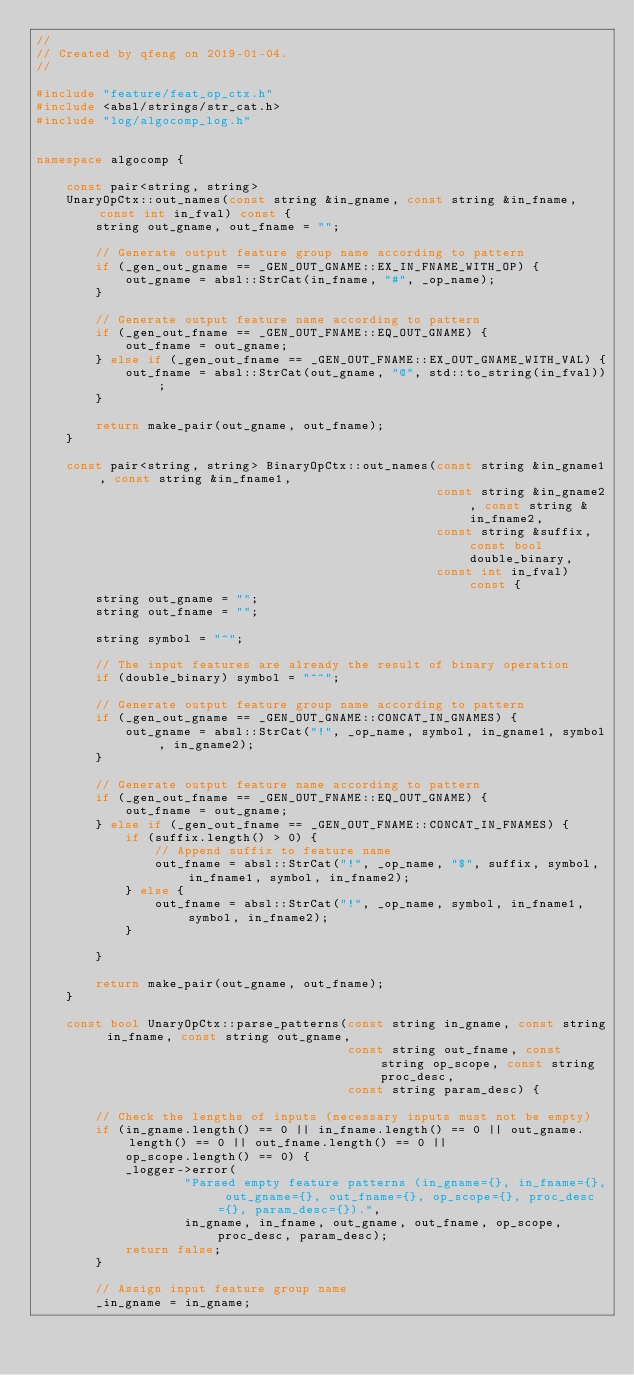Convert code to text. <code><loc_0><loc_0><loc_500><loc_500><_C++_>//
// Created by qfeng on 2019-01-04.
//

#include "feature/feat_op_ctx.h"
#include <absl/strings/str_cat.h>
#include "log/algocomp_log.h"


namespace algocomp {

    const pair<string, string>
    UnaryOpCtx::out_names(const string &in_gname, const string &in_fname, const int in_fval) const {
        string out_gname, out_fname = "";

        // Generate output feature group name according to pattern
        if (_gen_out_gname == _GEN_OUT_GNAME::EX_IN_FNAME_WITH_OP) {
            out_gname = absl::StrCat(in_fname, "#", _op_name);
        }

        // Generate output feature name according to pattern
        if (_gen_out_fname == _GEN_OUT_FNAME::EQ_OUT_GNAME) {
            out_fname = out_gname;
        } else if (_gen_out_fname == _GEN_OUT_FNAME::EX_OUT_GNAME_WITH_VAL) {
            out_fname = absl::StrCat(out_gname, "@", std::to_string(in_fval));
        }

        return make_pair(out_gname, out_fname);
    }

    const pair<string, string> BinaryOpCtx::out_names(const string &in_gname1, const string &in_fname1,
                                                      const string &in_gname2, const string &in_fname2,
                                                      const string &suffix, const bool double_binary,
                                                      const int in_fval) const {
        string out_gname = "";
        string out_fname = "";

        string symbol = "^";

        // The input features are already the result of binary operation
        if (double_binary) symbol = "^^";

        // Generate output feature group name according to pattern
        if (_gen_out_gname == _GEN_OUT_GNAME::CONCAT_IN_GNAMES) {
            out_gname = absl::StrCat("!", _op_name, symbol, in_gname1, symbol, in_gname2);
        }

        // Generate output feature name according to pattern
        if (_gen_out_fname == _GEN_OUT_FNAME::EQ_OUT_GNAME) {
            out_fname = out_gname;
        } else if (_gen_out_fname == _GEN_OUT_FNAME::CONCAT_IN_FNAMES) {
            if (suffix.length() > 0) {
                // Append suffix to feature name
                out_fname = absl::StrCat("!", _op_name, "$", suffix, symbol, in_fname1, symbol, in_fname2);
            } else {
                out_fname = absl::StrCat("!", _op_name, symbol, in_fname1, symbol, in_fname2);
            }

        }

        return make_pair(out_gname, out_fname);
    }

    const bool UnaryOpCtx::parse_patterns(const string in_gname, const string in_fname, const string out_gname,
                                          const string out_fname, const string op_scope, const string proc_desc,
                                          const string param_desc) {

        // Check the lengths of inputs (necessary inputs must not be empty)
        if (in_gname.length() == 0 || in_fname.length() == 0 || out_gname.length() == 0 || out_fname.length() == 0 ||
            op_scope.length() == 0) {
            _logger->error(
                    "Parsed empty feature patterns (in_gname={}, in_fname={}, out_gname={}, out_fname={}, op_scope={}, proc_desc={}, param_desc={}).",
                    in_gname, in_fname, out_gname, out_fname, op_scope, proc_desc, param_desc);
            return false;
        }

        // Assign input feature group name
        _in_gname = in_gname;
</code> 